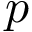Convert formula to latex. <formula><loc_0><loc_0><loc_500><loc_500>p</formula> 